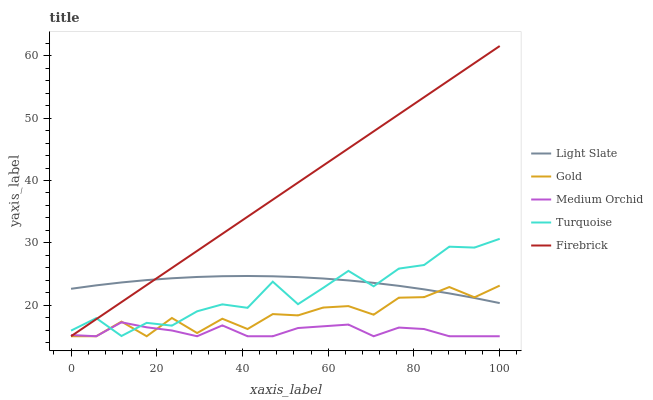Does Medium Orchid have the minimum area under the curve?
Answer yes or no. Yes. Does Firebrick have the maximum area under the curve?
Answer yes or no. Yes. Does Turquoise have the minimum area under the curve?
Answer yes or no. No. Does Turquoise have the maximum area under the curve?
Answer yes or no. No. Is Firebrick the smoothest?
Answer yes or no. Yes. Is Turquoise the roughest?
Answer yes or no. Yes. Is Medium Orchid the smoothest?
Answer yes or no. No. Is Medium Orchid the roughest?
Answer yes or no. No. Does Medium Orchid have the lowest value?
Answer yes or no. Yes. Does Turquoise have the lowest value?
Answer yes or no. No. Does Firebrick have the highest value?
Answer yes or no. Yes. Does Turquoise have the highest value?
Answer yes or no. No. Is Medium Orchid less than Light Slate?
Answer yes or no. Yes. Is Light Slate greater than Medium Orchid?
Answer yes or no. Yes. Does Light Slate intersect Firebrick?
Answer yes or no. Yes. Is Light Slate less than Firebrick?
Answer yes or no. No. Is Light Slate greater than Firebrick?
Answer yes or no. No. Does Medium Orchid intersect Light Slate?
Answer yes or no. No. 